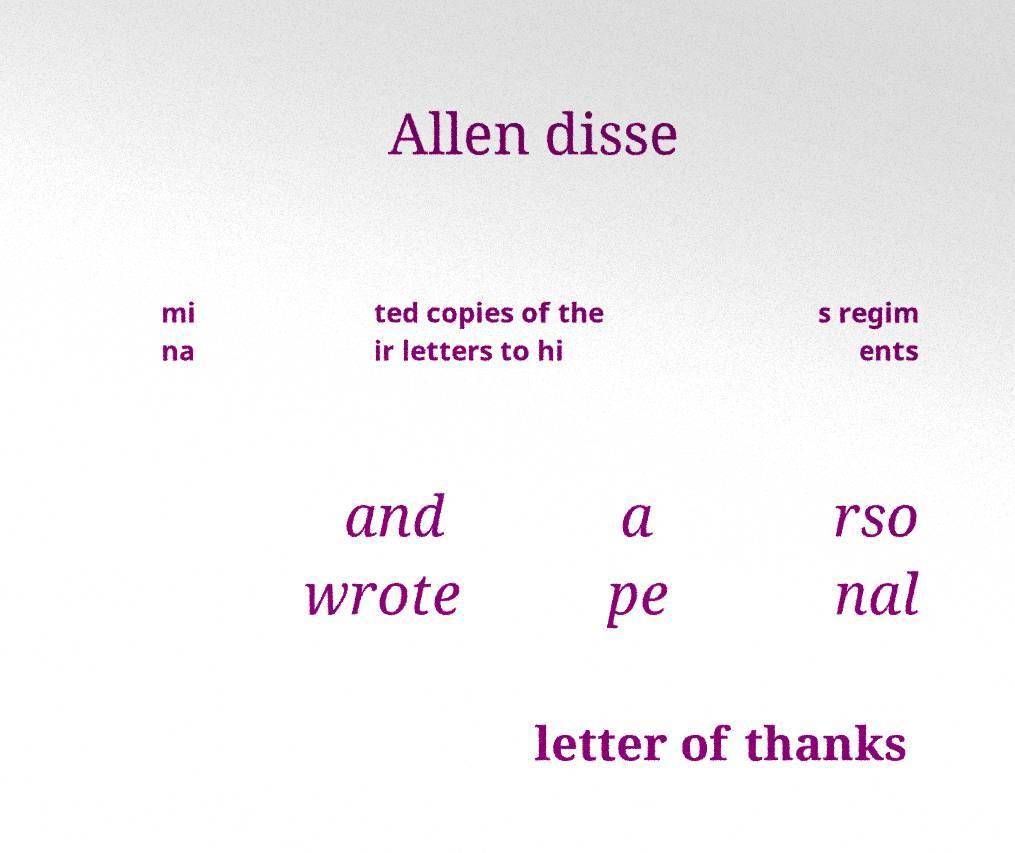Could you assist in decoding the text presented in this image and type it out clearly? Allen disse mi na ted copies of the ir letters to hi s regim ents and wrote a pe rso nal letter of thanks 